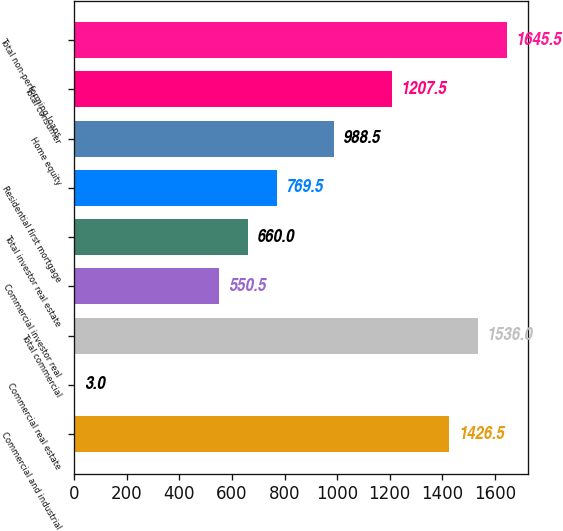<chart> <loc_0><loc_0><loc_500><loc_500><bar_chart><fcel>Commercial and industrial<fcel>Commercial real estate<fcel>Total commercial<fcel>Commercial investor real<fcel>Total investor real estate<fcel>Residential first mortgage<fcel>Home equity<fcel>Total consumer<fcel>Total non-performing loans<nl><fcel>1426.5<fcel>3<fcel>1536<fcel>550.5<fcel>660<fcel>769.5<fcel>988.5<fcel>1207.5<fcel>1645.5<nl></chart> 